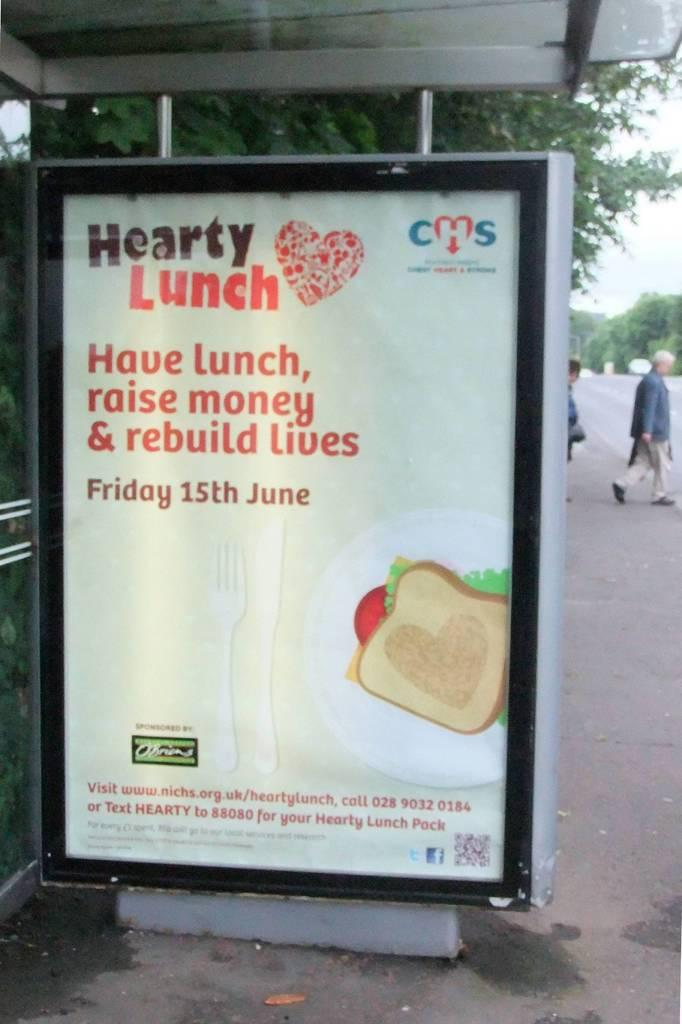<image>
Give a short and clear explanation of the subsequent image. Sign outdoors that says Have lunch, raise money and rebuild lives. 